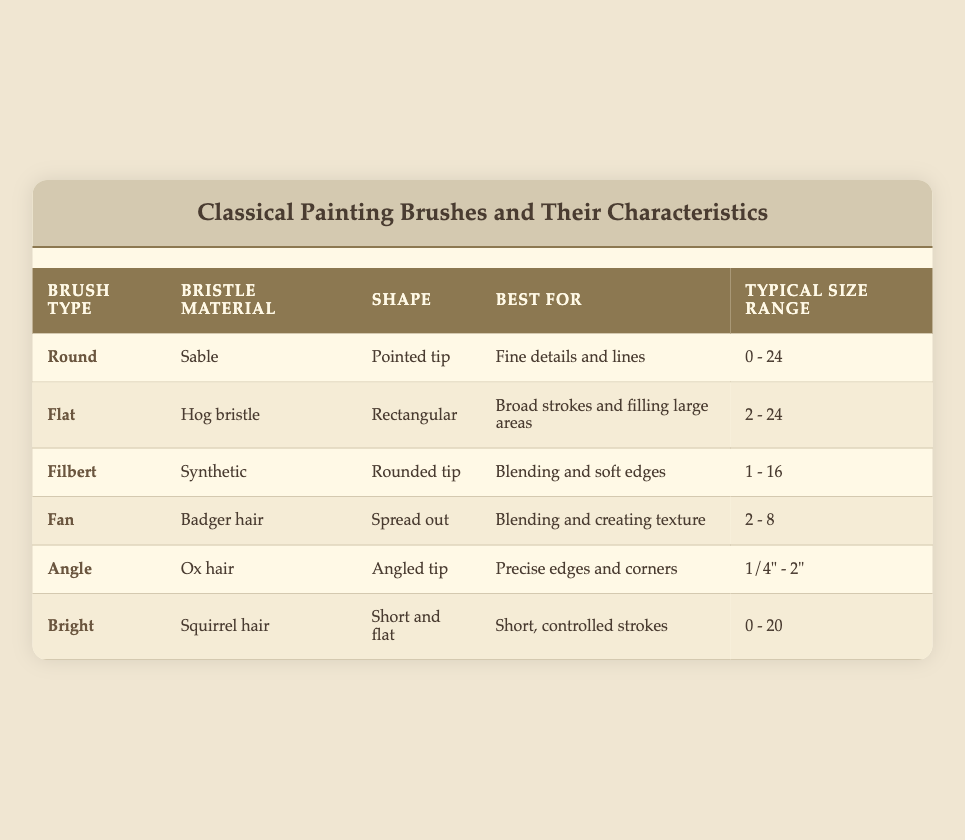What is the bristle material of the Round brush? The Round brush has a bristle material made of Sable. This information can be found in the corresponding row of the table.
Answer: Sable Which brush type is best for blending and soft edges? The Filbert brush type is specifically noted as being best for blending and soft edges, as indicated in the table under the "Best For" column for that brush type.
Answer: Filbert What is the typical size range for the Flat brush? The Flat brush's typical size range is listed as 2 - 24. It can be found by examining the row of the Flat brush in the size range column.
Answer: 2 - 24 Is the Fan brush made of synthetic material? No, the Fan brush is made of Badger hair, as indicated in the table. The bristle material is specifically stated in the relevant row of the table.
Answer: No Which brush type has the shortest typical size range? The Fan brush has the shortest typical size range of 2 - 8. To find this, one needs to compare the size ranges of all the brushes in the table, noting that Fan has the smallest upper limit.
Answer: Fan 